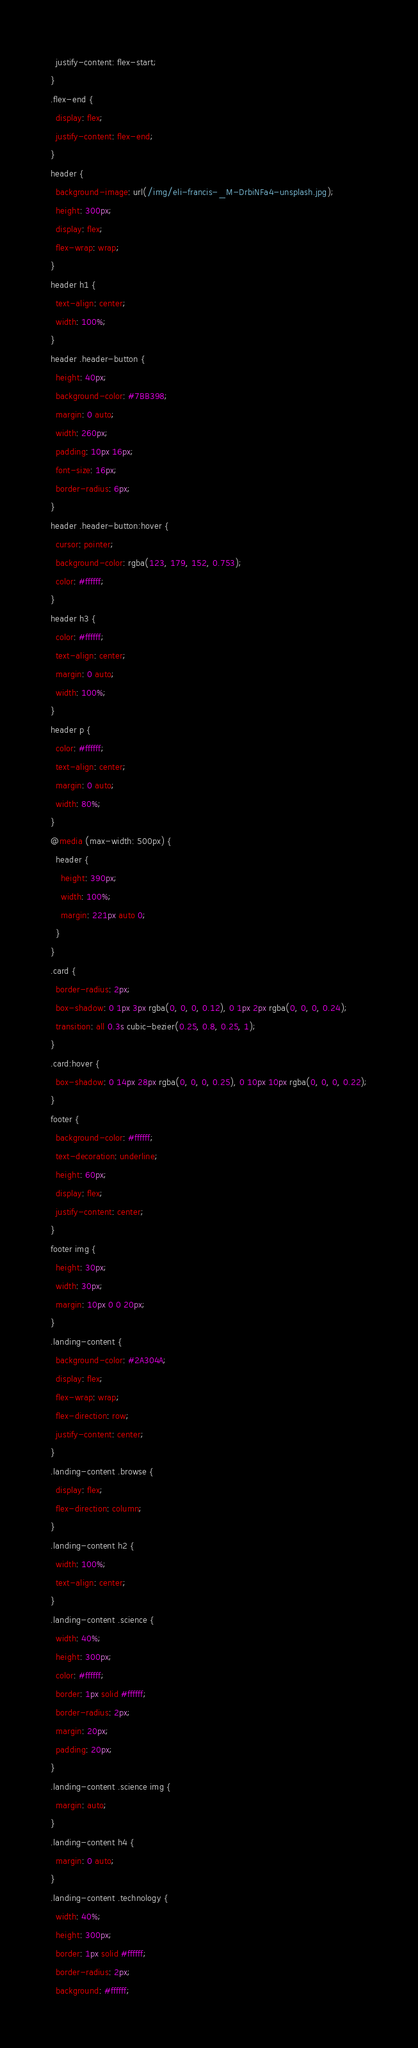<code> <loc_0><loc_0><loc_500><loc_500><_CSS_>  justify-content: flex-start;
}
.flex-end {
  display: flex;
  justify-content: flex-end;
}
header {
  background-image: url(/img/eli-francis-_M-DrbiNFa4-unsplash.jpg);
  height: 300px;
  display: flex;
  flex-wrap: wrap;
}
header h1 {
  text-align: center;
  width: 100%;
}
header .header-button {
  height: 40px;
  background-color: #7BB398;
  margin: 0 auto;
  width: 260px;
  padding: 10px 16px;
  font-size: 16px;
  border-radius: 6px;
}
header .header-button:hover {
  cursor: pointer;
  background-color: rgba(123, 179, 152, 0.753);
  color: #ffffff;
}
header h3 {
  color: #ffffff;
  text-align: center;
  margin: 0 auto;
  width: 100%;
}
header p {
  color: #ffffff;
  text-align: center;
  margin: 0 auto;
  width: 80%;
}
@media (max-width: 500px) {
  header {
    height: 390px;
    width: 100%;
    margin: 221px auto 0;
  }
}
.card {
  border-radius: 2px;
  box-shadow: 0 1px 3px rgba(0, 0, 0, 0.12), 0 1px 2px rgba(0, 0, 0, 0.24);
  transition: all 0.3s cubic-bezier(0.25, 0.8, 0.25, 1);
}
.card:hover {
  box-shadow: 0 14px 28px rgba(0, 0, 0, 0.25), 0 10px 10px rgba(0, 0, 0, 0.22);
}
footer {
  background-color: #ffffff;
  text-decoration: underline;
  height: 60px;
  display: flex;
  justify-content: center;
}
footer img {
  height: 30px;
  width: 30px;
  margin: 10px 0 0 20px;
}
.landing-content {
  background-color: #2A304A;
  display: flex;
  flex-wrap: wrap;
  flex-direction: row;
  justify-content: center;
}
.landing-content .browse {
  display: flex;
  flex-direction: column;
}
.landing-content h2 {
  width: 100%;
  text-align: center;
}
.landing-content .science {
  width: 40%;
  height: 300px;
  color: #ffffff;
  border: 1px solid #ffffff;
  border-radius: 2px;
  margin: 20px;
  padding: 20px;
}
.landing-content .science img {
  margin: auto;
}
.landing-content h4 {
  margin: 0 auto;
}
.landing-content .technology {
  width: 40%;
  height: 300px;
  border: 1px solid #ffffff;
  border-radius: 2px;
  background: #ffffff;</code> 